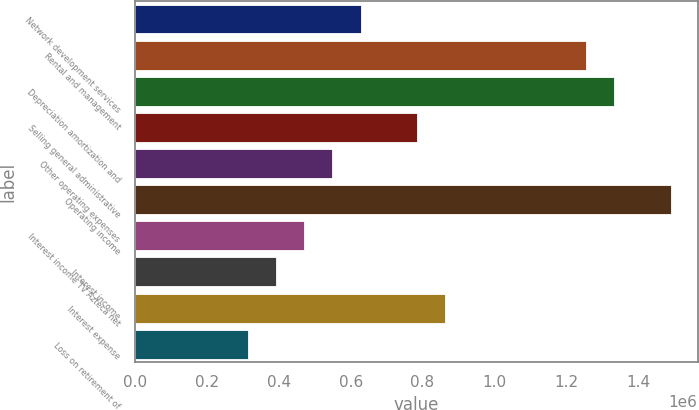<chart> <loc_0><loc_0><loc_500><loc_500><bar_chart><fcel>Network development services<fcel>Rental and management<fcel>Depreciation amortization and<fcel>Selling general administrative<fcel>Other operating expenses<fcel>Operating income<fcel>Interest income TV Azteca net<fcel>Interest income<fcel>Interest expense<fcel>Loss on retirement of<nl><fcel>627508<fcel>1.25499e+06<fcel>1.33342e+06<fcel>784378<fcel>549074<fcel>1.49029e+06<fcel>470639<fcel>392204<fcel>862813<fcel>313769<nl></chart> 